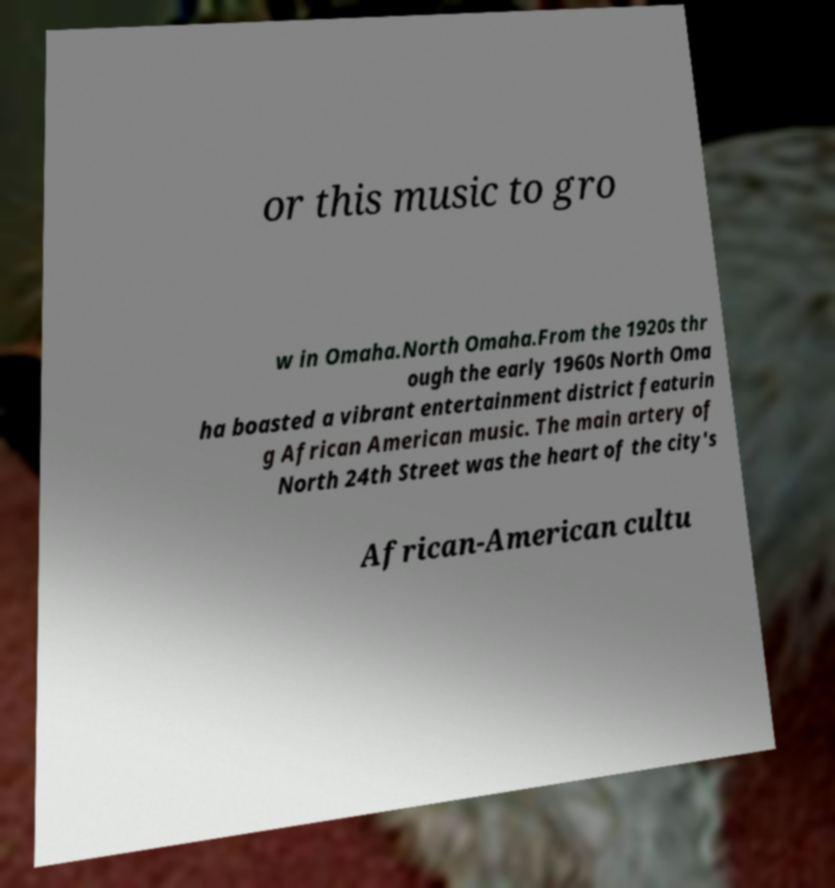Can you read and provide the text displayed in the image?This photo seems to have some interesting text. Can you extract and type it out for me? or this music to gro w in Omaha.North Omaha.From the 1920s thr ough the early 1960s North Oma ha boasted a vibrant entertainment district featurin g African American music. The main artery of North 24th Street was the heart of the city's African-American cultu 